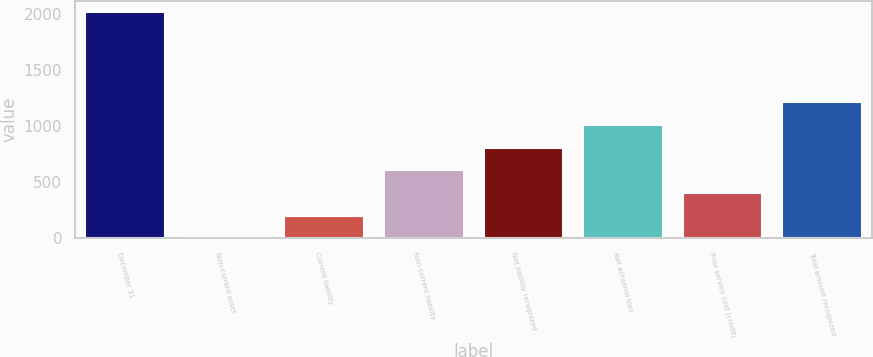Convert chart. <chart><loc_0><loc_0><loc_500><loc_500><bar_chart><fcel>December 31<fcel>Non-current asset<fcel>Current liability<fcel>Non-current liability<fcel>Net liability recognized<fcel>Net actuarial loss<fcel>Prior service cost (credit)<fcel>Total amount recognized<nl><fcel>2015<fcel>0.71<fcel>202.14<fcel>605<fcel>806.43<fcel>1007.86<fcel>403.57<fcel>1209.29<nl></chart> 